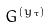Convert formula to latex. <formula><loc_0><loc_0><loc_500><loc_500>G ^ { ( y _ { \tau } ) }</formula> 